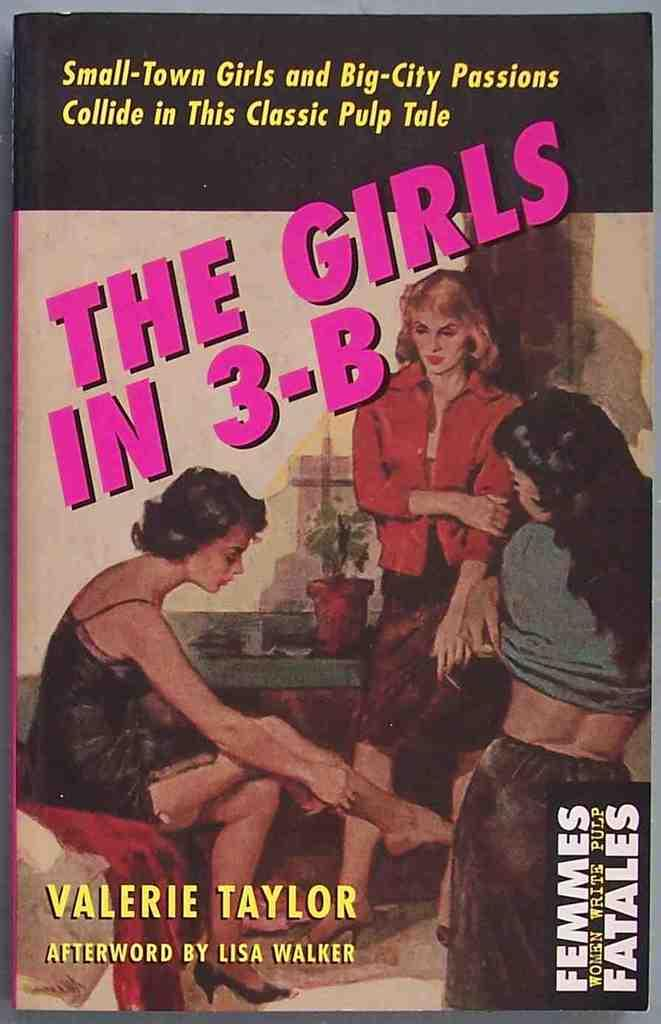<image>
Render a clear and concise summary of the photo. Book cover for The Girls in 3-B by Valerie Taylor showing three woman having a conversation. 